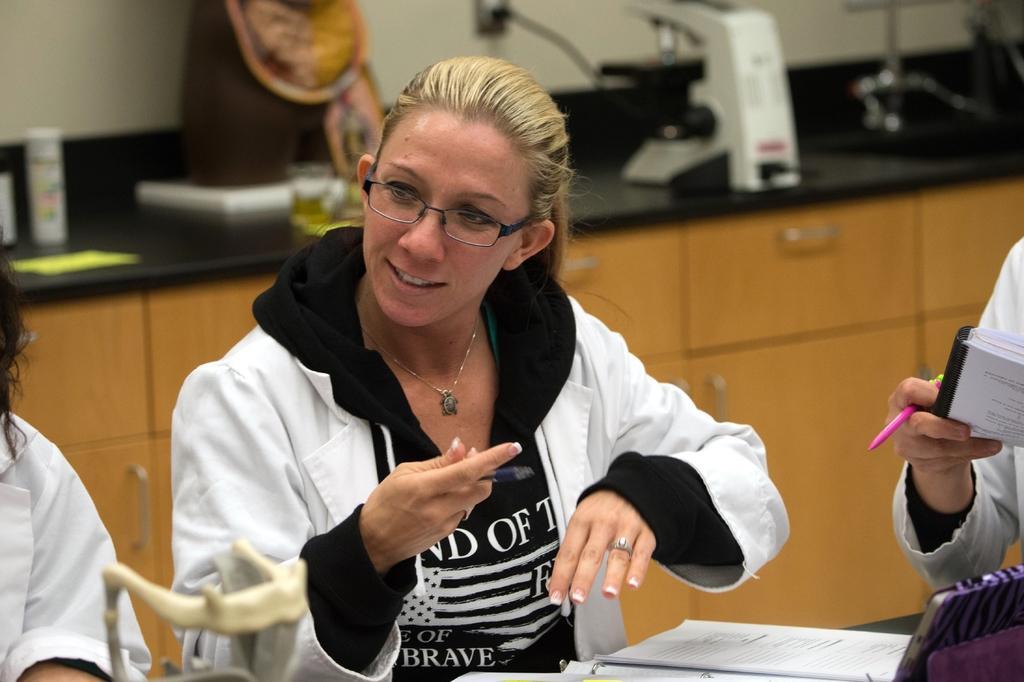Describe this image in one or two sentences. In the center of the image we can see a person sitting at the table and holding a pen. On the table we can see tablet and book. On the right and left side of the image we can see persons. In the background we can see countertop and cupboards. On the countertop we can see microscope and some objects. 